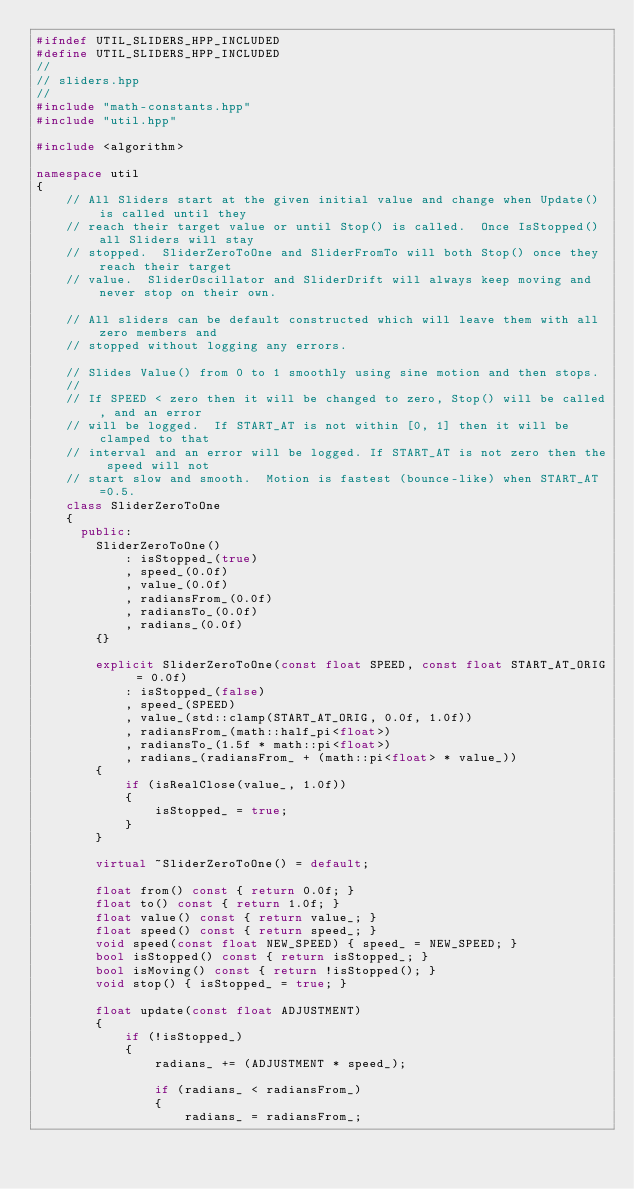Convert code to text. <code><loc_0><loc_0><loc_500><loc_500><_C++_>#ifndef UTIL_SLIDERS_HPP_INCLUDED
#define UTIL_SLIDERS_HPP_INCLUDED
//
// sliders.hpp
//
#include "math-constants.hpp"
#include "util.hpp"

#include <algorithm>

namespace util
{
    // All Sliders start at the given initial value and change when Update() is called until they
    // reach their target value or until Stop() is called.  Once IsStopped() all Sliders will stay
    // stopped.  SliderZeroToOne and SliderFromTo will both Stop() once they reach their target
    // value.  SliderOscillator and SliderDrift will always keep moving and never stop on their own.

    // All sliders can be default constructed which will leave them with all zero members and
    // stopped without logging any errors.

    // Slides Value() from 0 to 1 smoothly using sine motion and then stops.
    //
    // If SPEED < zero then it will be changed to zero, Stop() will be called, and an error
    // will be logged.  If START_AT is not within [0, 1] then it will be clamped to that
    // interval and an error will be logged. If START_AT is not zero then the speed will not
    // start slow and smooth.  Motion is fastest (bounce-like) when START_AT=0.5.
    class SliderZeroToOne
    {
      public:
        SliderZeroToOne()
            : isStopped_(true)
            , speed_(0.0f)
            , value_(0.0f)
            , radiansFrom_(0.0f)
            , radiansTo_(0.0f)
            , radians_(0.0f)
        {}

        explicit SliderZeroToOne(const float SPEED, const float START_AT_ORIG = 0.0f)
            : isStopped_(false)
            , speed_(SPEED)
            , value_(std::clamp(START_AT_ORIG, 0.0f, 1.0f))
            , radiansFrom_(math::half_pi<float>)
            , radiansTo_(1.5f * math::pi<float>)
            , radians_(radiansFrom_ + (math::pi<float> * value_))
        {
            if (isRealClose(value_, 1.0f))
            {
                isStopped_ = true;
            }
        }

        virtual ~SliderZeroToOne() = default;

        float from() const { return 0.0f; }
        float to() const { return 1.0f; }
        float value() const { return value_; }
        float speed() const { return speed_; }
        void speed(const float NEW_SPEED) { speed_ = NEW_SPEED; }
        bool isStopped() const { return isStopped_; }
        bool isMoving() const { return !isStopped(); }
        void stop() { isStopped_ = true; }

        float update(const float ADJUSTMENT)
        {
            if (!isStopped_)
            {
                radians_ += (ADJUSTMENT * speed_);

                if (radians_ < radiansFrom_)
                {
                    radians_ = radiansFrom_;</code> 